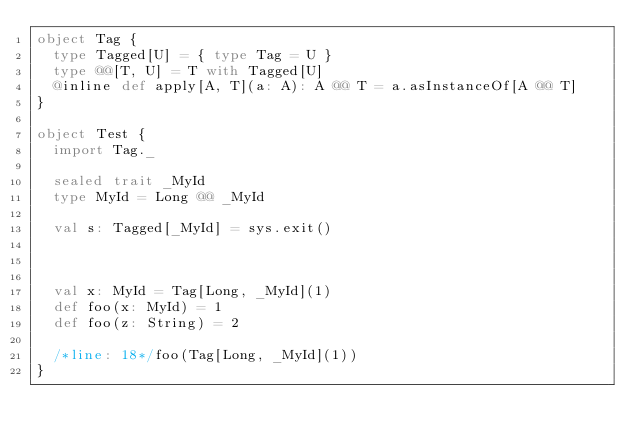Convert code to text. <code><loc_0><loc_0><loc_500><loc_500><_Scala_>object Tag {
  type Tagged[U] = { type Tag = U }
  type @@[T, U] = T with Tagged[U]
  @inline def apply[A, T](a: A): A @@ T = a.asInstanceOf[A @@ T]
}

object Test {
  import Tag._

  sealed trait _MyId
  type MyId = Long @@ _MyId

  val s: Tagged[_MyId] = sys.exit()



  val x: MyId = Tag[Long, _MyId](1)
  def foo(x: MyId) = 1
  def foo(z: String) = 2

  /*line: 18*/foo(Tag[Long, _MyId](1))
}</code> 